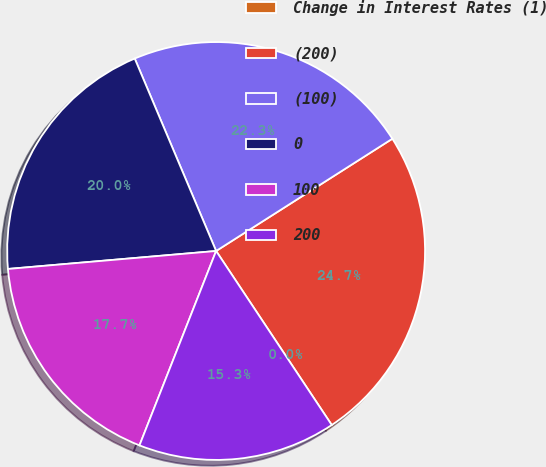<chart> <loc_0><loc_0><loc_500><loc_500><pie_chart><fcel>Change in Interest Rates (1)<fcel>(200)<fcel>(100)<fcel>0<fcel>100<fcel>200<nl><fcel>0.0%<fcel>24.69%<fcel>22.34%<fcel>20.0%<fcel>17.65%<fcel>15.31%<nl></chart> 